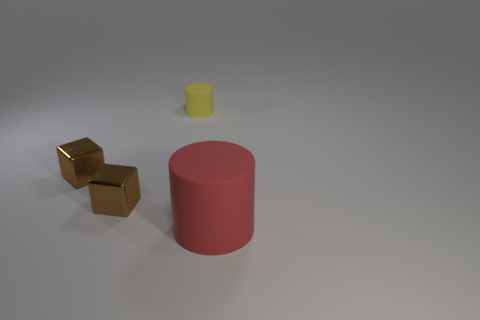Is there any other thing that has the same size as the red rubber cylinder?
Offer a very short reply. No. What number of brown blocks are the same size as the yellow cylinder?
Ensure brevity in your answer.  2. There is a cylinder in front of the tiny rubber cylinder; what is its material?
Provide a succinct answer. Rubber. What number of other big red rubber things have the same shape as the large thing?
Your answer should be very brief. 0. The rubber object to the left of the big red object that is in front of the rubber thing behind the big red matte object is what shape?
Offer a very short reply. Cylinder. Are there more big red things than big purple metallic cylinders?
Your answer should be compact. Yes. There is a yellow object that is the same shape as the large red thing; what is its material?
Offer a very short reply. Rubber. Do the big object and the tiny cylinder have the same material?
Offer a terse response. Yes. Is the number of tiny yellow matte objects that are on the left side of the tiny cylinder greater than the number of small gray matte cylinders?
Give a very brief answer. No. What material is the cylinder behind the rubber cylinder in front of the matte cylinder left of the big matte object?
Provide a short and direct response. Rubber. 